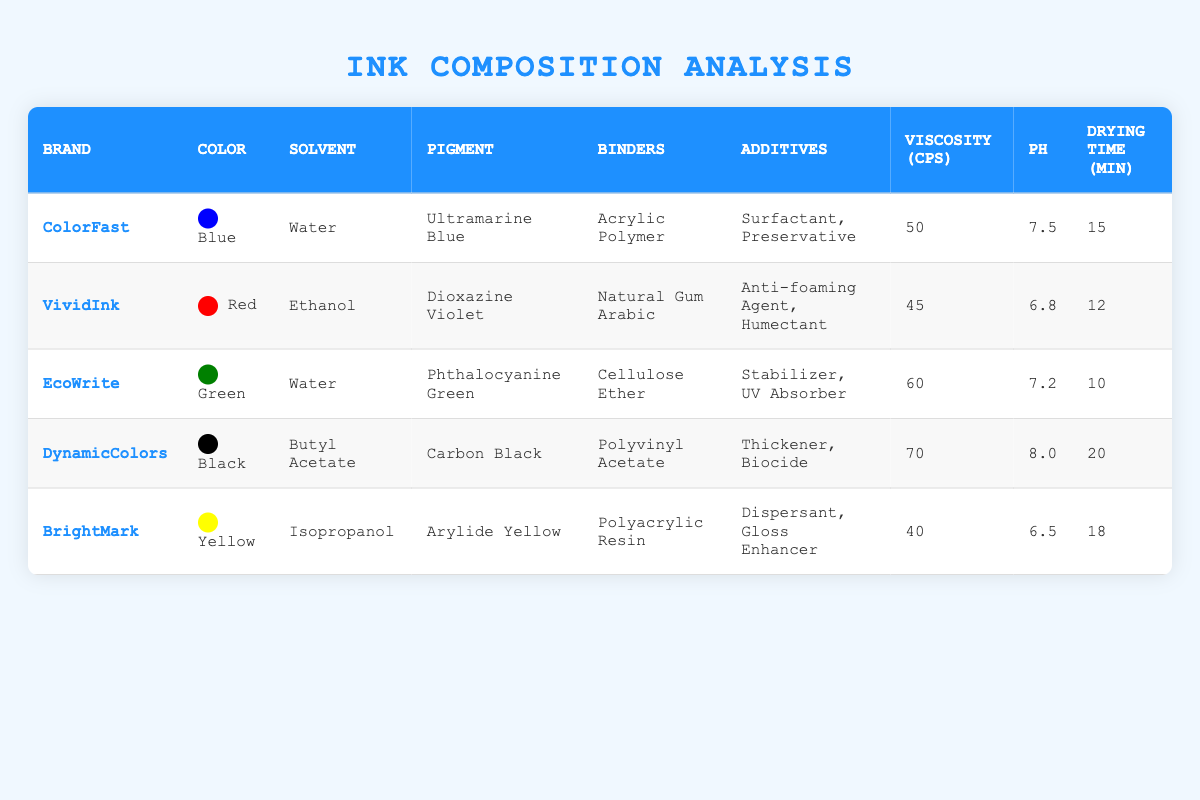What is the solvent used in the "DynamicColors" brand? The table lists "DynamicColors" under the brand column, with the solvent column showing "Butyl Acetate" next to it.
Answer: Butyl Acetate Which brand has the highest viscosity and what is its value? Looking through the viscosity column, "DynamicColors" shows the highest value of 70 cps, compared to the other brands listed.
Answer: 70 cps Is the pH of the "ColorFast" ink above 7? The pH value listed for "ColorFast" is 7.5, which is greater than 7, confirming that it is indeed above 7.
Answer: Yes What is the average drying time of the inks listed? To find the average drying time, sum up all the drying times (15 + 12 + 10 + 20 + 18 = 85) and divide by the number of brands (5), which gives an average of 85/5 = 17.
Answer: 17 minutes Which ink has the least amount of additives? The "VividInk" brand has the least number of additives listed (2: Anti-foaming Agent, Humectant), while others have more.
Answer: VividInk What color pigment does the "EcoWrite" ink use? The pigment column next to "EcoWrite" states "Phthalocyanine Green," identifying it as the pigment used.
Answer: Phthalocyanine Green Are there any inks with a viscosity less than 50 cps? By checking the viscosity values, "VividInk" has 45 cps and "BrightMark" has 40 cps, both are below 50 cps.
Answer: Yes What is the difference in viscosity between the "BrightMark" and the "EcoWrite" inks? The viscosity of "BrightMark" is 40 cps and "EcoWrite" is 60 cps; calculating the difference gives 60 - 40 = 20 cps.
Answer: 20 cps Which binding material is used in the "VividInk" ink? Under the binders column for "VividInk," it is stated as "Natural Gum Arabic."
Answer: Natural Gum Arabic Is there any ink brand with a drying time of less than 15 minutes that uses a water solvent? "EcoWrite" has a drying time of 10 minutes and uses water as a solvent, thus confirming the criteria.
Answer: Yes 